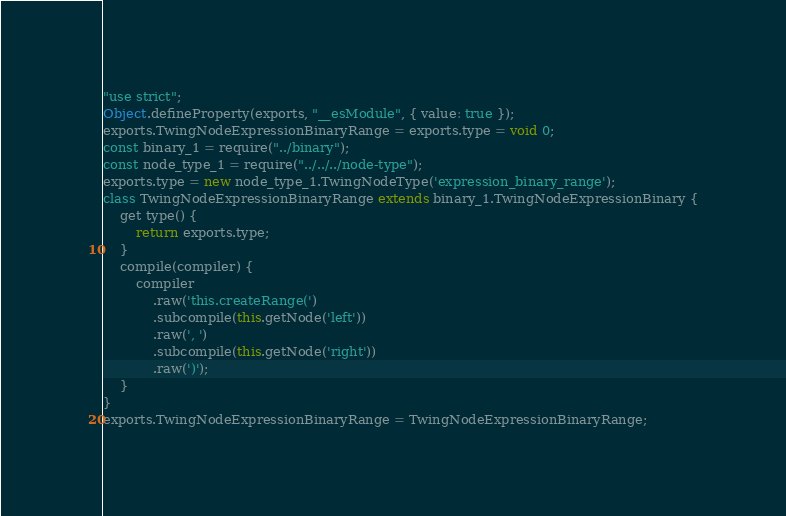<code> <loc_0><loc_0><loc_500><loc_500><_JavaScript_>"use strict";
Object.defineProperty(exports, "__esModule", { value: true });
exports.TwingNodeExpressionBinaryRange = exports.type = void 0;
const binary_1 = require("../binary");
const node_type_1 = require("../../../node-type");
exports.type = new node_type_1.TwingNodeType('expression_binary_range');
class TwingNodeExpressionBinaryRange extends binary_1.TwingNodeExpressionBinary {
    get type() {
        return exports.type;
    }
    compile(compiler) {
        compiler
            .raw('this.createRange(')
            .subcompile(this.getNode('left'))
            .raw(', ')
            .subcompile(this.getNode('right'))
            .raw(')');
    }
}
exports.TwingNodeExpressionBinaryRange = TwingNodeExpressionBinaryRange;
</code> 